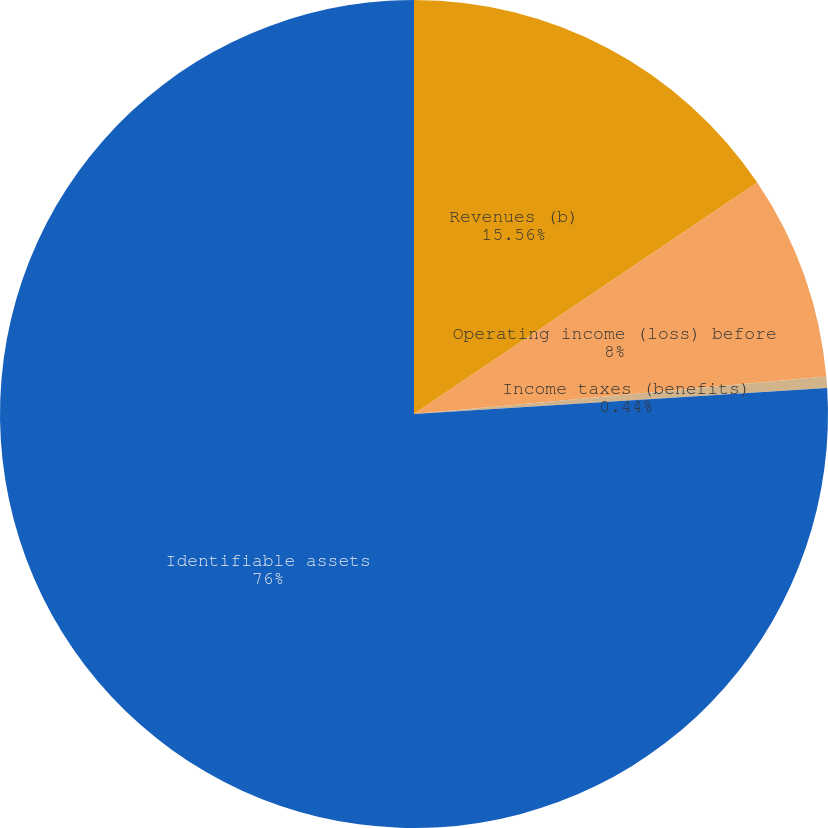Convert chart to OTSL. <chart><loc_0><loc_0><loc_500><loc_500><pie_chart><fcel>Revenues (b)<fcel>Operating income (loss) before<fcel>Income taxes (benefits)<fcel>Identifiable assets<nl><fcel>15.56%<fcel>8.0%<fcel>0.44%<fcel>76.0%<nl></chart> 